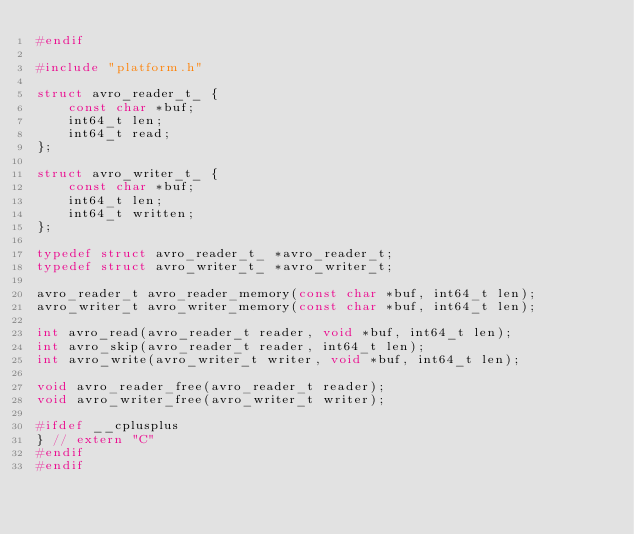<code> <loc_0><loc_0><loc_500><loc_500><_C_>#endif

#include "platform.h"

struct avro_reader_t_ {
    const char *buf;
    int64_t len;
    int64_t read;
};

struct avro_writer_t_ {
    const char *buf;
    int64_t len;
    int64_t written;
};

typedef struct avro_reader_t_ *avro_reader_t;
typedef struct avro_writer_t_ *avro_writer_t;

avro_reader_t avro_reader_memory(const char *buf, int64_t len);
avro_writer_t avro_writer_memory(const char *buf, int64_t len);

int avro_read(avro_reader_t reader, void *buf, int64_t len);
int avro_skip(avro_reader_t reader, int64_t len);
int avro_write(avro_writer_t writer, void *buf, int64_t len);

void avro_reader_free(avro_reader_t reader);
void avro_writer_free(avro_writer_t writer);

#ifdef __cplusplus
} // extern "C"
#endif
#endif
</code> 